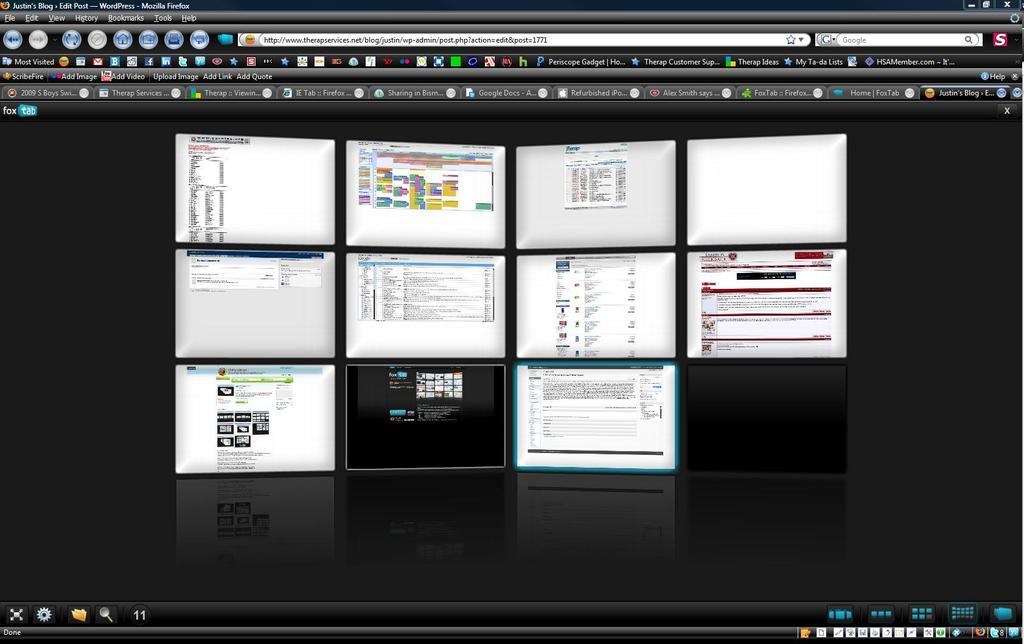<image>
Present a compact description of the photo's key features. a firefox window open with different pages on the screen 